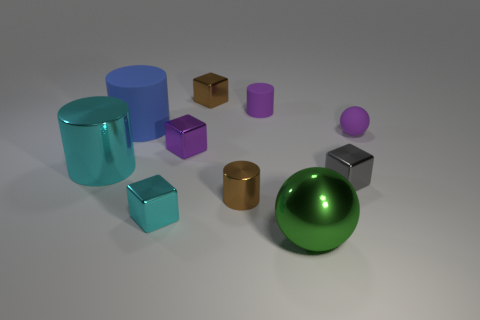Subtract 1 blocks. How many blocks are left? 3 Subtract all green blocks. Subtract all red balls. How many blocks are left? 4 Subtract all spheres. How many objects are left? 8 Add 5 red rubber objects. How many red rubber objects exist? 5 Subtract 0 yellow cylinders. How many objects are left? 10 Subtract all brown cylinders. Subtract all small cyan objects. How many objects are left? 8 Add 6 purple matte cylinders. How many purple matte cylinders are left? 7 